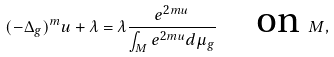Convert formula to latex. <formula><loc_0><loc_0><loc_500><loc_500>( - \Delta _ { g } ) ^ { m } u + \lambda = \lambda \frac { e ^ { 2 m u } } { \int _ { M } e ^ { 2 m u } d \mu _ { g } } \quad \text {on } M ,</formula> 